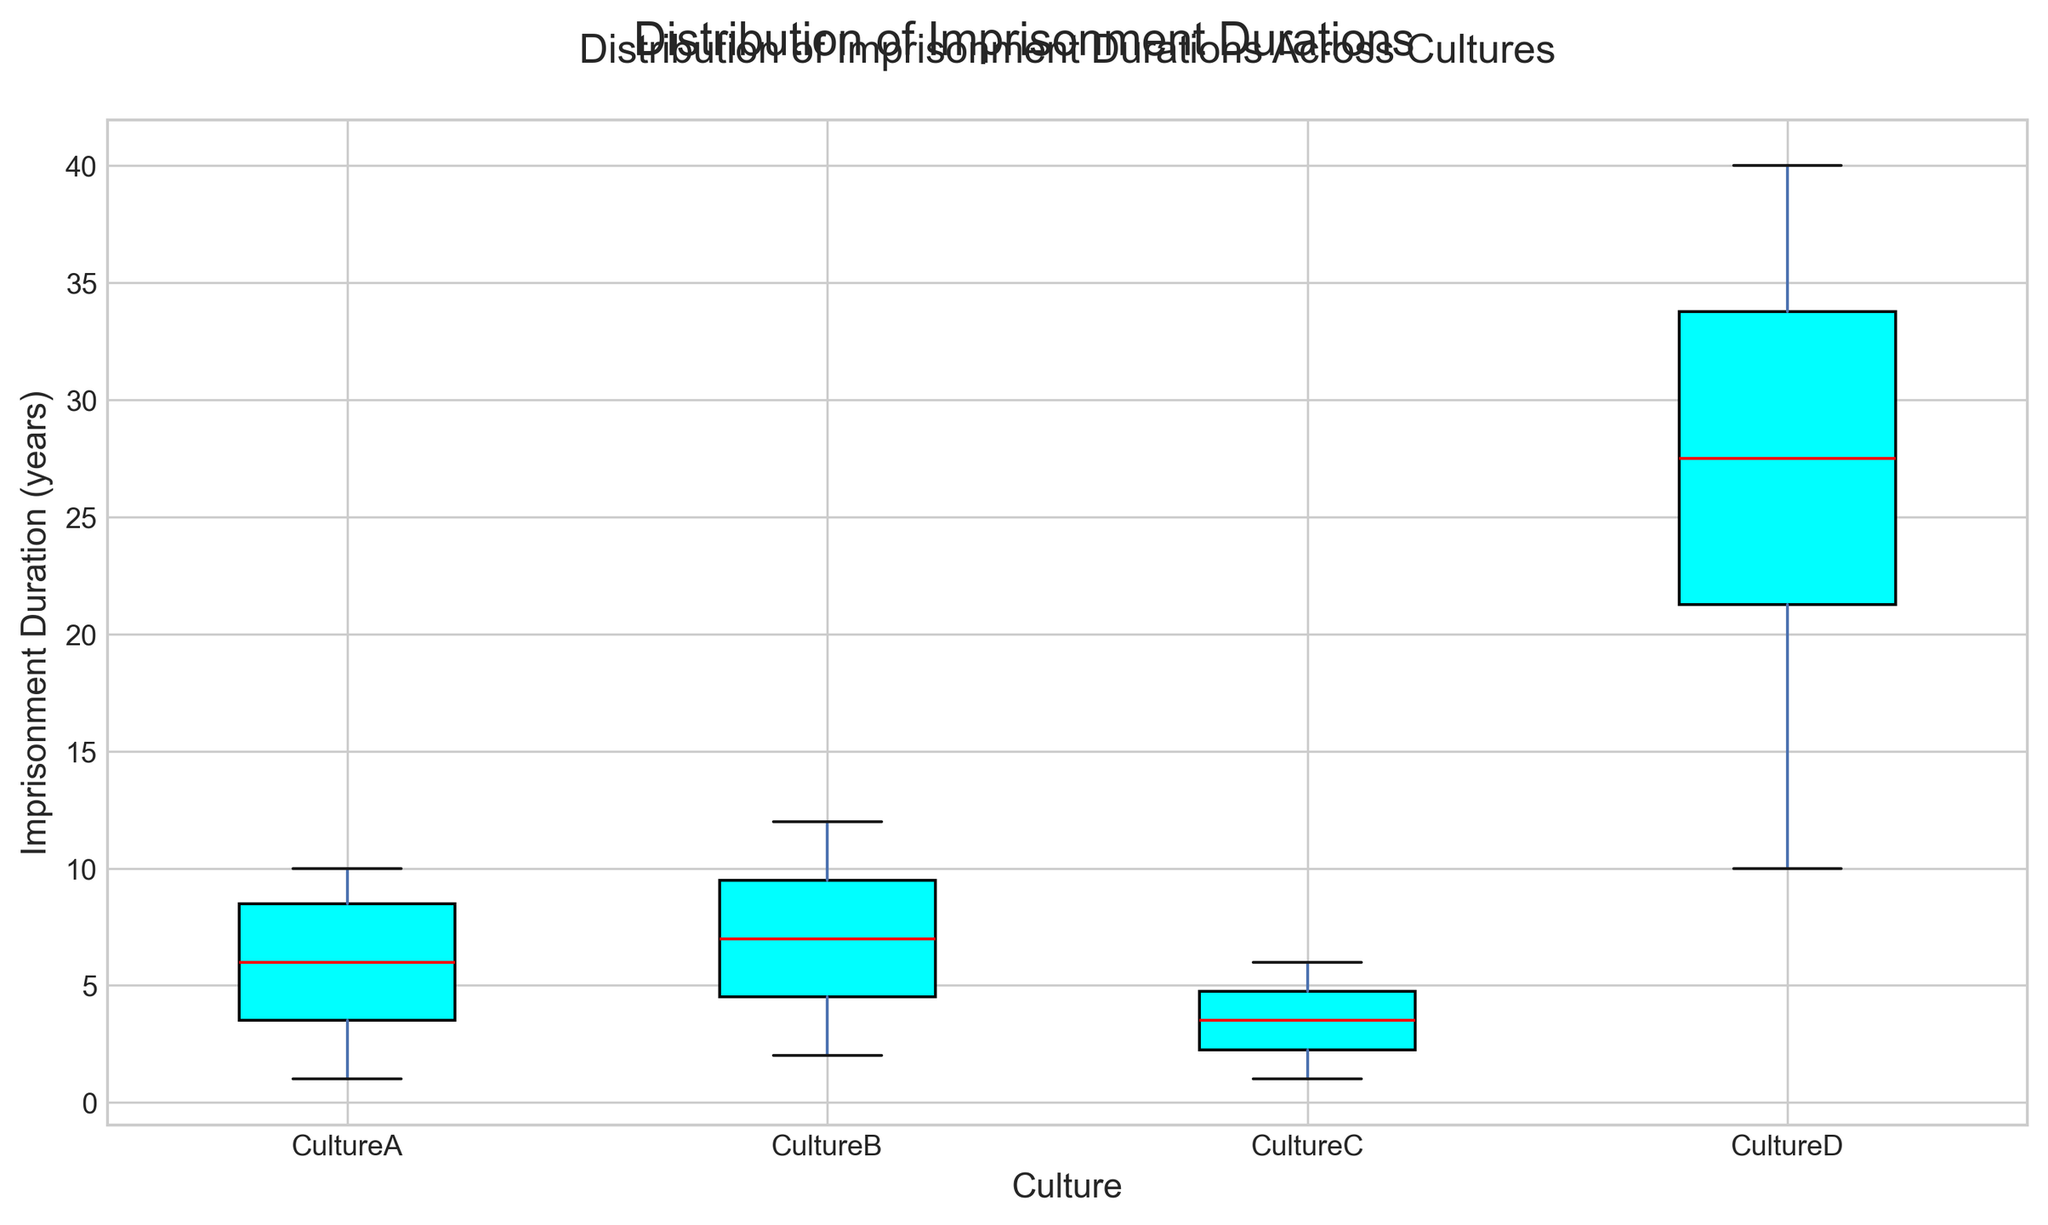Which culture has the highest median imprisonment duration? The median is represented by the red line inside each box. By visual observation, the boxplot for Culture D has the highest median imprisonment duration.
Answer: Culture D Compare the median imprisonment duration of Culture A and Culture C. Which one is higher? The median line (in red) inside Culture C's box is lower than that of Culture A. Therefore, Culture A has a higher median imprisonment duration.
Answer: Culture A What is the interquartile range (IQR) for Culture B? The IQR is the difference between the upper quartile (Q3) and the lower quartile (Q1). For Culture B, Q3 is around 9, and Q1 is around 3, so the IQR is 9 - 3.
Answer: 6 Which culture has the widest range of imprisonment durations? The range is the difference between the maximum and minimum values. Culture D spans from 10 to 40, a range of 30, which is wider than other cultures.
Answer: Culture D Is the median imprisonment duration in Culture C closer to the minimum or maximum value of the imprisonment durations in the same culture? In the boxplot for Culture C, the median (red line) is closer to the bottom of the box. Therefore, it is closer to the minimum value.
Answer: Minimum Are there any cultures with identical minimum or maximum imprisonment durations? Both Culture A and Culture C have their minimum imprisonment duration at the same level, around 1 year. However, they do not share the maximum value.
Answer: Yes, minimum Which culture has the most symmetric distribution of imprisonment durations? A symmetric distribution appears as a box where the median is centered. Culture C appears most symmetric, as the median line is near the center of the box.
Answer: Culture C Compare the median imprisonment durations between Culture B and Culture D. How much higher is Culture D compared to Culture B? The median for Culture B is around 8, while for Culture D, it is around 27. The difference is approximately 27 - 8.
Answer: 19 Are there any outliers visible for Culture A? In boxplots, outliers are typically represented by points outside the whiskers. For Culture A, there are no points outside its whiskers; hence, no outliers.
Answer: No Which culture has the smallest interquartile range (IQR), and what is its value? The smallest IQR can be observed by the height of the boxes. Culture C has the smallest IQR, and it ranges from about 2 to 5, making the IQR 5 - 2.
Answer: Culture C, 3 